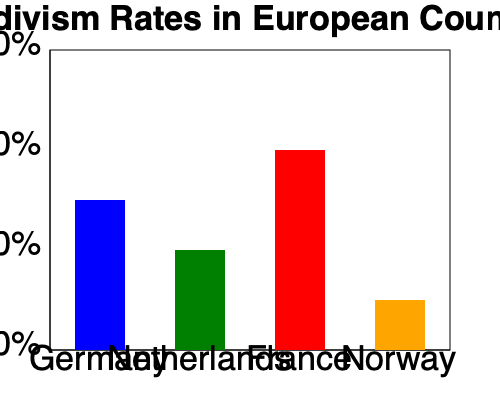Based on the bar chart comparing recidivism rates across different European countries, which country has the lowest recidivism rate, and what potential factors might contribute to this lower rate? To answer this question, we need to analyze the bar chart and consider the context of criminal justice systems in Europe:

1. Examine the bar chart:
   - Germany: approximately 30% recidivism rate
   - Netherlands: approximately 20% recidivism rate
   - France: approximately 40% recidivism rate
   - Norway: approximately 10% recidivism rate

2. Identify the country with the lowest recidivism rate:
   Norway has the shortest bar, indicating the lowest recidivism rate at about 10%.

3. Consider potential factors contributing to Norway's lower recidivism rate:
   a) Rehabilitation-focused approach: Norway is known for its emphasis on rehabilitation rather than punishment in its prison system.
   b) Humane prison conditions: Norwegian prisons often provide more comfortable living conditions and educational opportunities.
   c) Shorter sentences: Norway tends to have shorter prison sentences compared to many other countries.
   d) Strong social support system: Norway has a robust welfare system that helps reintegrate former prisoners into society.
   e) Focus on restorative justice: Norway emphasizes making amends and repairing harm caused by crimes.
   f) Low unemployment and inequality: Norway's strong economy and social equality may reduce incentives for reoffending.

These factors combined likely contribute to Norway's lower recidivism rate compared to other European countries shown in the chart.
Answer: Norway; rehabilitation-focused approach, humane prison conditions, shorter sentences, strong social support, restorative justice emphasis, and low unemployment/inequality. 